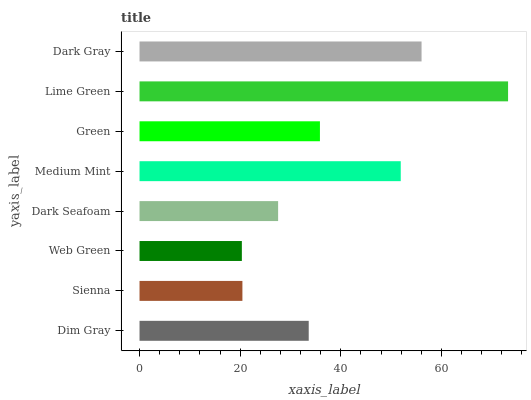Is Web Green the minimum?
Answer yes or no. Yes. Is Lime Green the maximum?
Answer yes or no. Yes. Is Sienna the minimum?
Answer yes or no. No. Is Sienna the maximum?
Answer yes or no. No. Is Dim Gray greater than Sienna?
Answer yes or no. Yes. Is Sienna less than Dim Gray?
Answer yes or no. Yes. Is Sienna greater than Dim Gray?
Answer yes or no. No. Is Dim Gray less than Sienna?
Answer yes or no. No. Is Green the high median?
Answer yes or no. Yes. Is Dim Gray the low median?
Answer yes or no. Yes. Is Web Green the high median?
Answer yes or no. No. Is Dark Gray the low median?
Answer yes or no. No. 